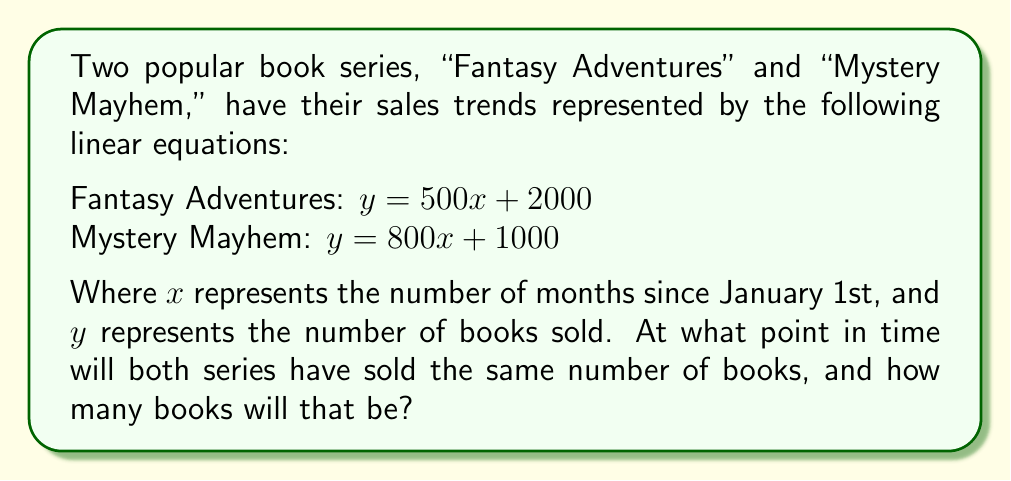Can you answer this question? To find the intersection point of these two lines, we need to solve the system of equations:

$$
\begin{cases}
y = 500x + 2000 \\
y = 800x + 1000
\end{cases}
$$

1) Since both equations are equal to $y$, we can set them equal to each other:

   $500x + 2000 = 800x + 1000$

2) Subtract $500x$ from both sides:

   $2000 = 300x + 1000$

3) Subtract 1000 from both sides:

   $1000 = 300x$

4) Divide both sides by 300:

   $\frac{1000}{300} = x$

5) Simplify:

   $\frac{10}{3} = x$

6) To find $y$, we can substitute this $x$ value into either of the original equations. Let's use the first one:

   $y = 500(\frac{10}{3}) + 2000$

7) Simplify:

   $y = \frac{5000}{3} + 2000 = \frac{5000}{3} + \frac{6000}{3} = \frac{11000}{3}$

Therefore, the intersection point is $(\frac{10}{3}, \frac{11000}{3})$.

To interpret this result:
- $x = \frac{10}{3}$ months ≈ 3.33 months, which is about 3 months and 10 days after January 1st (around April 10th).
- $y = \frac{11000}{3}$ ≈ 3667 books sold for each series at that time.
Answer: The two book series will have sold the same number of books approximately 3 months and 10 days after January 1st (around April 10th), with each series having sold about 3,667 books at that time. The exact intersection point is $(\frac{10}{3}, \frac{11000}{3})$. 